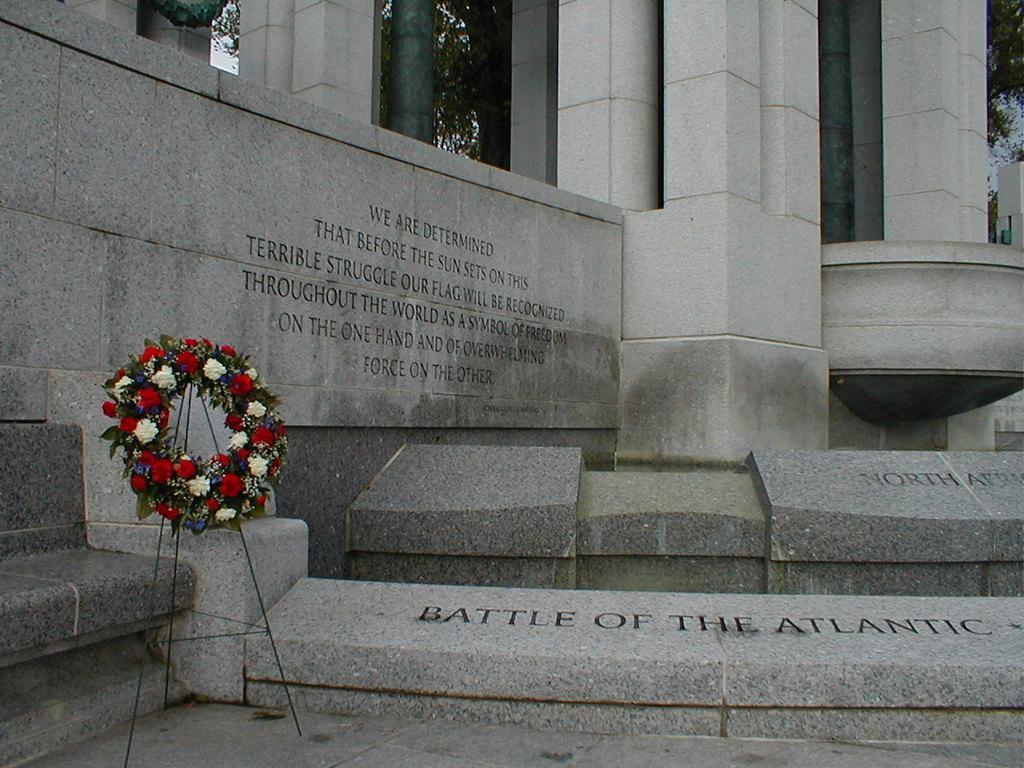Please provide a concise description of this image. In this image I can see a building, garland on a stand and a text. At the top I can see trees. This image is taken may be during a day. 